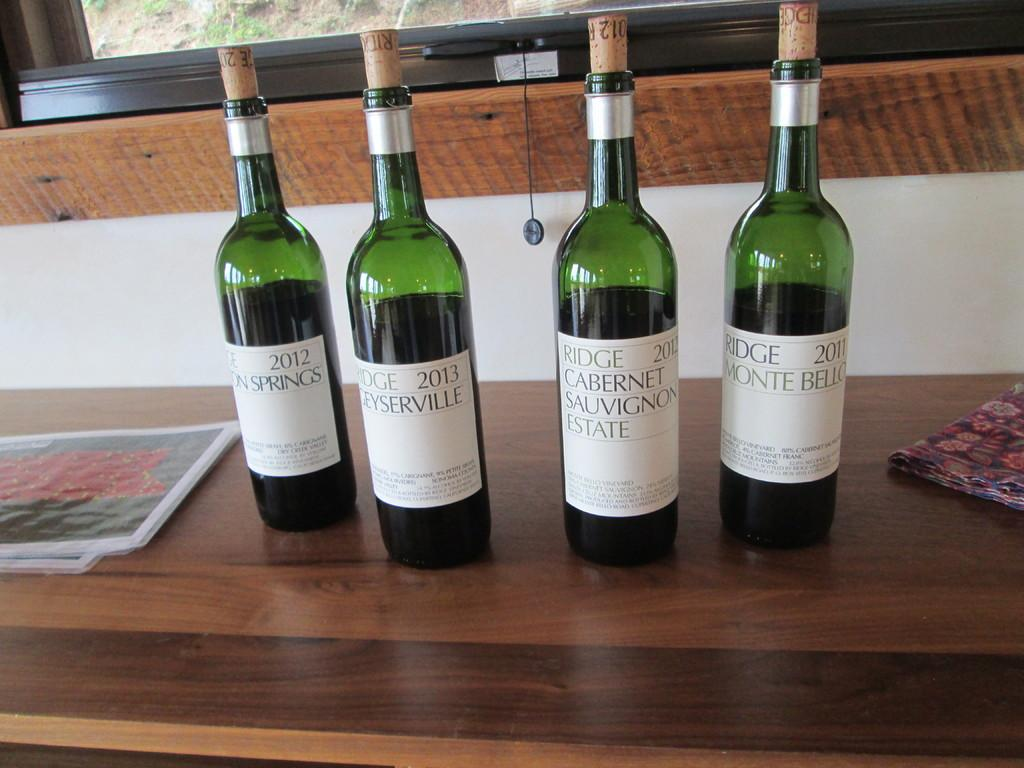What is located in the middle of the image? There is a table in the middle of the image. What is on top of the table? There is a paper and a cloth on the table. How many bottles are on the table? There are 4 bottles on the table. What can be seen in the background of the image? There is a wall and a window in the background of the image. What type of dinosaurs can be seen walking through the window in the image? There are no dinosaurs present in the image, and therefore no such activity can be observed. 